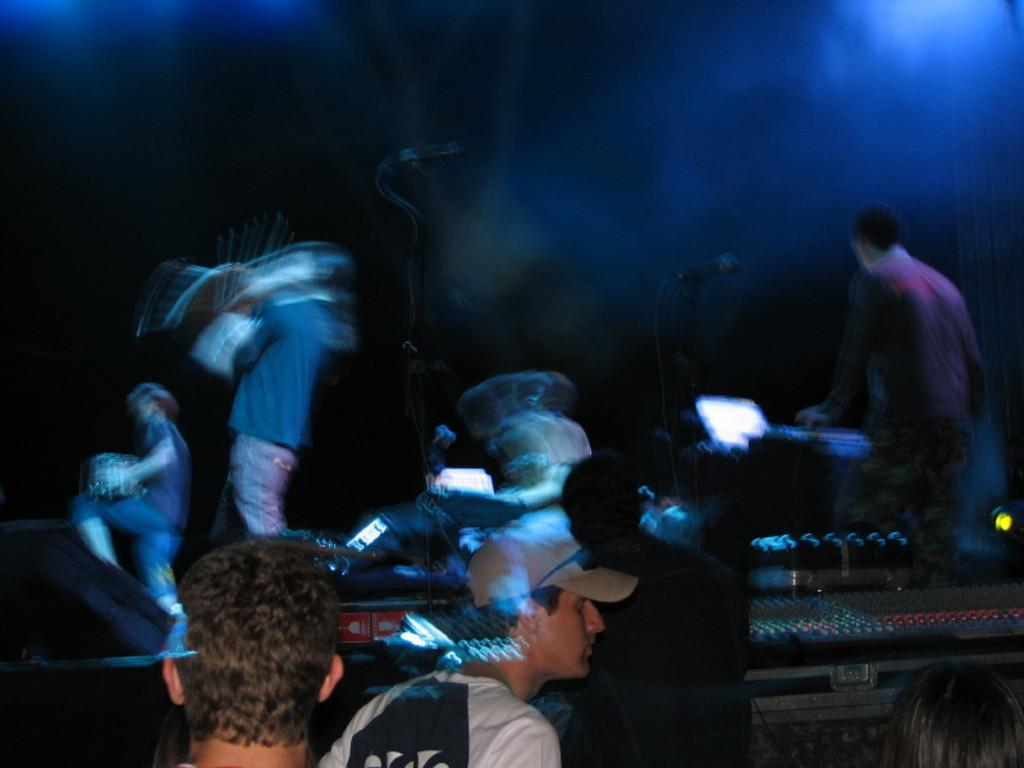What can be seen in the image involving multiple individuals? There is a group of people in the image. What are the people in the image doing? Musical instruments are present in the image, suggesting that the people are playing music. What equipment is visible in the image for amplifying sound? There are microphones with stands in the image. What else can be seen in the image besides the people and musical equipment? There are other objects in the image. How can the background of the image be described? The background of the image is dark. What type of letter is being cooked by the people in the image? There is no letter or cooking activity present in the image. What is the back of the image showing? The provided facts do not mention anything about the back of the image, as we are only considering what is visible in the image. 